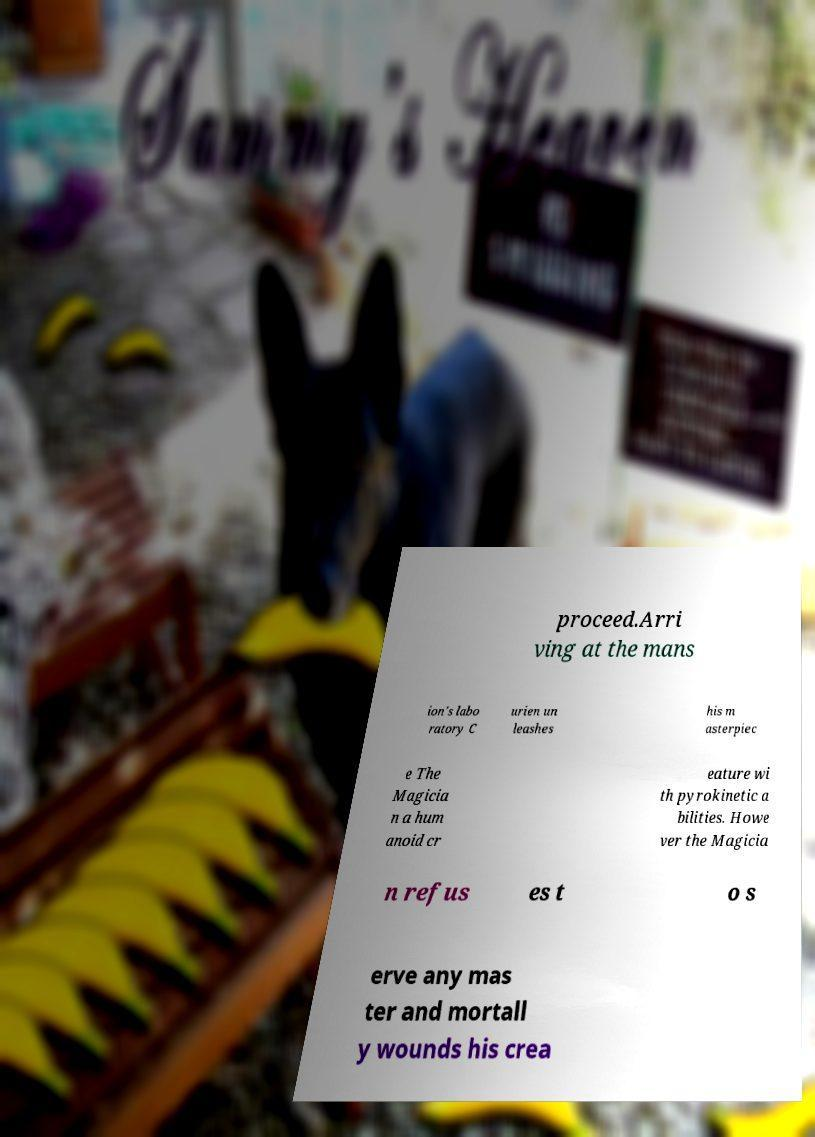For documentation purposes, I need the text within this image transcribed. Could you provide that? proceed.Arri ving at the mans ion's labo ratory C urien un leashes his m asterpiec e The Magicia n a hum anoid cr eature wi th pyrokinetic a bilities. Howe ver the Magicia n refus es t o s erve any mas ter and mortall y wounds his crea 